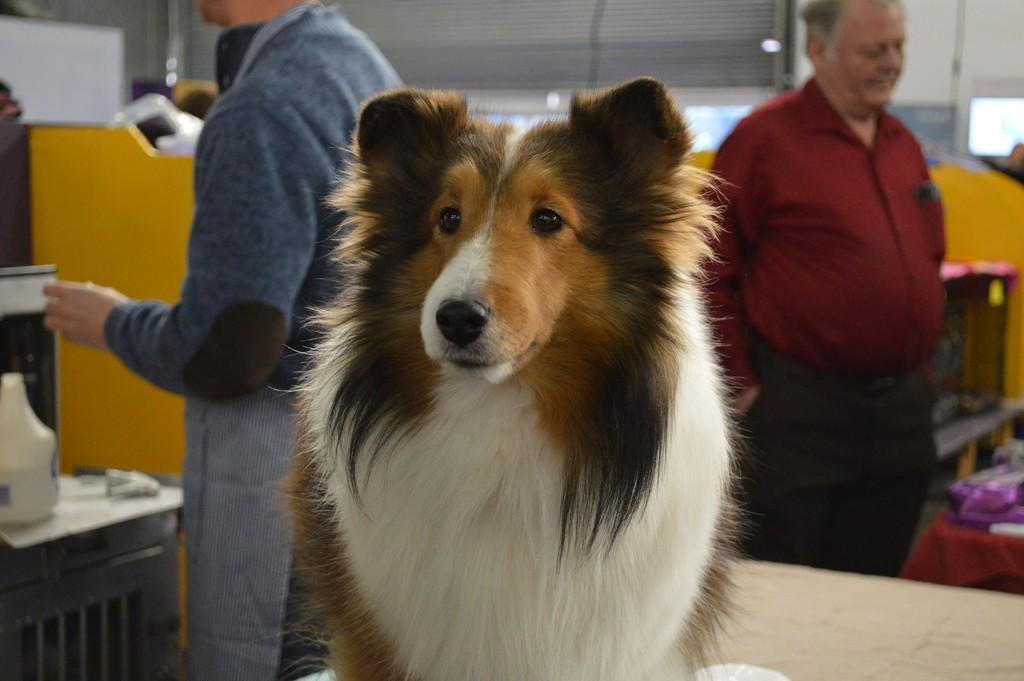Could you give a brief overview of what you see in this image? In this picture I can see a dog and two persons are standing on the floor. In the background I can see wall and some other objects. The man on the right side is wearing shirt and pant. 